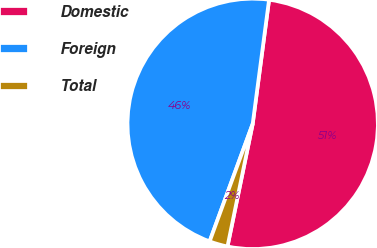<chart> <loc_0><loc_0><loc_500><loc_500><pie_chart><fcel>Domestic<fcel>Foreign<fcel>Total<nl><fcel>51.14%<fcel>46.5%<fcel>2.36%<nl></chart> 